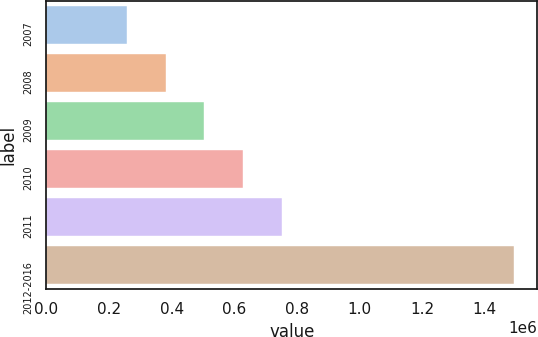<chart> <loc_0><loc_0><loc_500><loc_500><bar_chart><fcel>2007<fcel>2008<fcel>2009<fcel>2010<fcel>2011<fcel>2012-2016<nl><fcel>257782<fcel>381360<fcel>504937<fcel>628515<fcel>752093<fcel>1.49356e+06<nl></chart> 